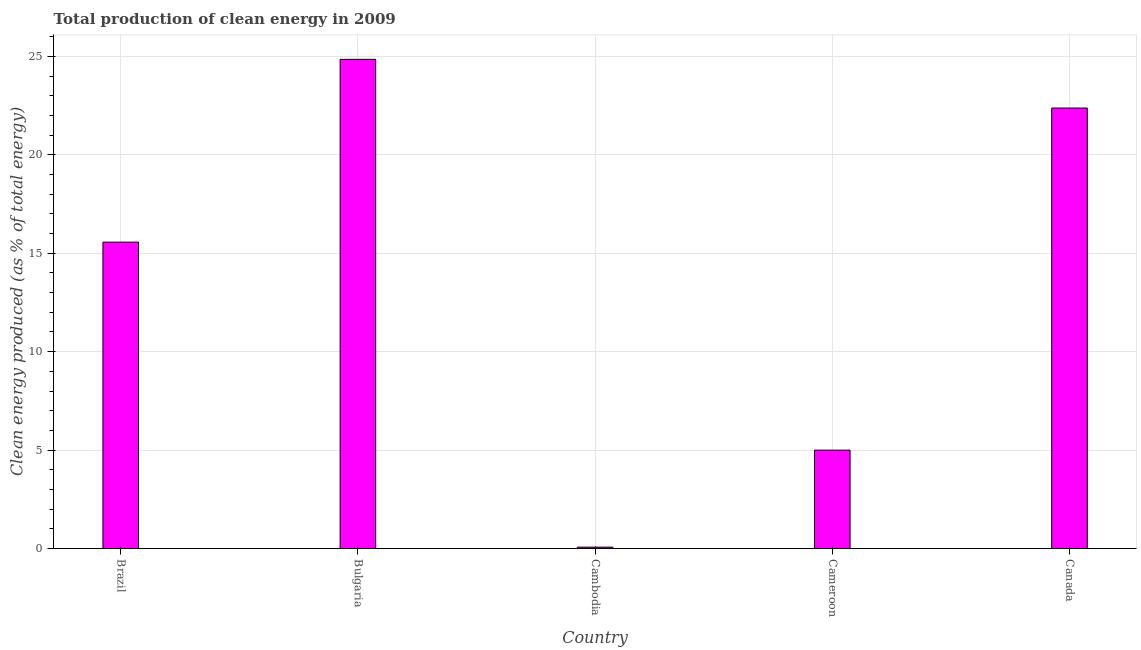Does the graph contain grids?
Provide a short and direct response. Yes. What is the title of the graph?
Make the answer very short. Total production of clean energy in 2009. What is the label or title of the X-axis?
Make the answer very short. Country. What is the label or title of the Y-axis?
Your response must be concise. Clean energy produced (as % of total energy). What is the production of clean energy in Cambodia?
Keep it short and to the point. 0.07. Across all countries, what is the maximum production of clean energy?
Provide a short and direct response. 24.85. Across all countries, what is the minimum production of clean energy?
Offer a terse response. 0.07. In which country was the production of clean energy maximum?
Make the answer very short. Bulgaria. In which country was the production of clean energy minimum?
Your response must be concise. Cambodia. What is the sum of the production of clean energy?
Provide a succinct answer. 67.85. What is the difference between the production of clean energy in Cambodia and Canada?
Make the answer very short. -22.31. What is the average production of clean energy per country?
Ensure brevity in your answer.  13.57. What is the median production of clean energy?
Provide a succinct answer. 15.56. What is the ratio of the production of clean energy in Brazil to that in Cameroon?
Offer a very short reply. 3.12. What is the difference between the highest and the second highest production of clean energy?
Offer a very short reply. 2.47. Is the sum of the production of clean energy in Bulgaria and Cambodia greater than the maximum production of clean energy across all countries?
Keep it short and to the point. Yes. What is the difference between the highest and the lowest production of clean energy?
Provide a short and direct response. 24.78. How many bars are there?
Your answer should be very brief. 5. Are all the bars in the graph horizontal?
Your response must be concise. No. How many countries are there in the graph?
Ensure brevity in your answer.  5. What is the difference between two consecutive major ticks on the Y-axis?
Provide a succinct answer. 5. Are the values on the major ticks of Y-axis written in scientific E-notation?
Keep it short and to the point. No. What is the Clean energy produced (as % of total energy) in Brazil?
Offer a very short reply. 15.56. What is the Clean energy produced (as % of total energy) in Bulgaria?
Keep it short and to the point. 24.85. What is the Clean energy produced (as % of total energy) of Cambodia?
Provide a short and direct response. 0.07. What is the Clean energy produced (as % of total energy) in Cameroon?
Provide a short and direct response. 5. What is the Clean energy produced (as % of total energy) in Canada?
Keep it short and to the point. 22.37. What is the difference between the Clean energy produced (as % of total energy) in Brazil and Bulgaria?
Offer a very short reply. -9.29. What is the difference between the Clean energy produced (as % of total energy) in Brazil and Cambodia?
Keep it short and to the point. 15.49. What is the difference between the Clean energy produced (as % of total energy) in Brazil and Cameroon?
Your answer should be very brief. 10.57. What is the difference between the Clean energy produced (as % of total energy) in Brazil and Canada?
Offer a terse response. -6.81. What is the difference between the Clean energy produced (as % of total energy) in Bulgaria and Cambodia?
Make the answer very short. 24.78. What is the difference between the Clean energy produced (as % of total energy) in Bulgaria and Cameroon?
Your answer should be very brief. 19.85. What is the difference between the Clean energy produced (as % of total energy) in Bulgaria and Canada?
Make the answer very short. 2.47. What is the difference between the Clean energy produced (as % of total energy) in Cambodia and Cameroon?
Offer a very short reply. -4.93. What is the difference between the Clean energy produced (as % of total energy) in Cambodia and Canada?
Your answer should be compact. -22.31. What is the difference between the Clean energy produced (as % of total energy) in Cameroon and Canada?
Ensure brevity in your answer.  -17.38. What is the ratio of the Clean energy produced (as % of total energy) in Brazil to that in Bulgaria?
Give a very brief answer. 0.63. What is the ratio of the Clean energy produced (as % of total energy) in Brazil to that in Cambodia?
Offer a very short reply. 227.67. What is the ratio of the Clean energy produced (as % of total energy) in Brazil to that in Cameroon?
Offer a terse response. 3.12. What is the ratio of the Clean energy produced (as % of total energy) in Brazil to that in Canada?
Provide a succinct answer. 0.7. What is the ratio of the Clean energy produced (as % of total energy) in Bulgaria to that in Cambodia?
Make the answer very short. 363.54. What is the ratio of the Clean energy produced (as % of total energy) in Bulgaria to that in Cameroon?
Provide a succinct answer. 4.97. What is the ratio of the Clean energy produced (as % of total energy) in Bulgaria to that in Canada?
Offer a terse response. 1.11. What is the ratio of the Clean energy produced (as % of total energy) in Cambodia to that in Cameroon?
Your answer should be very brief. 0.01. What is the ratio of the Clean energy produced (as % of total energy) in Cambodia to that in Canada?
Make the answer very short. 0. What is the ratio of the Clean energy produced (as % of total energy) in Cameroon to that in Canada?
Your response must be concise. 0.22. 